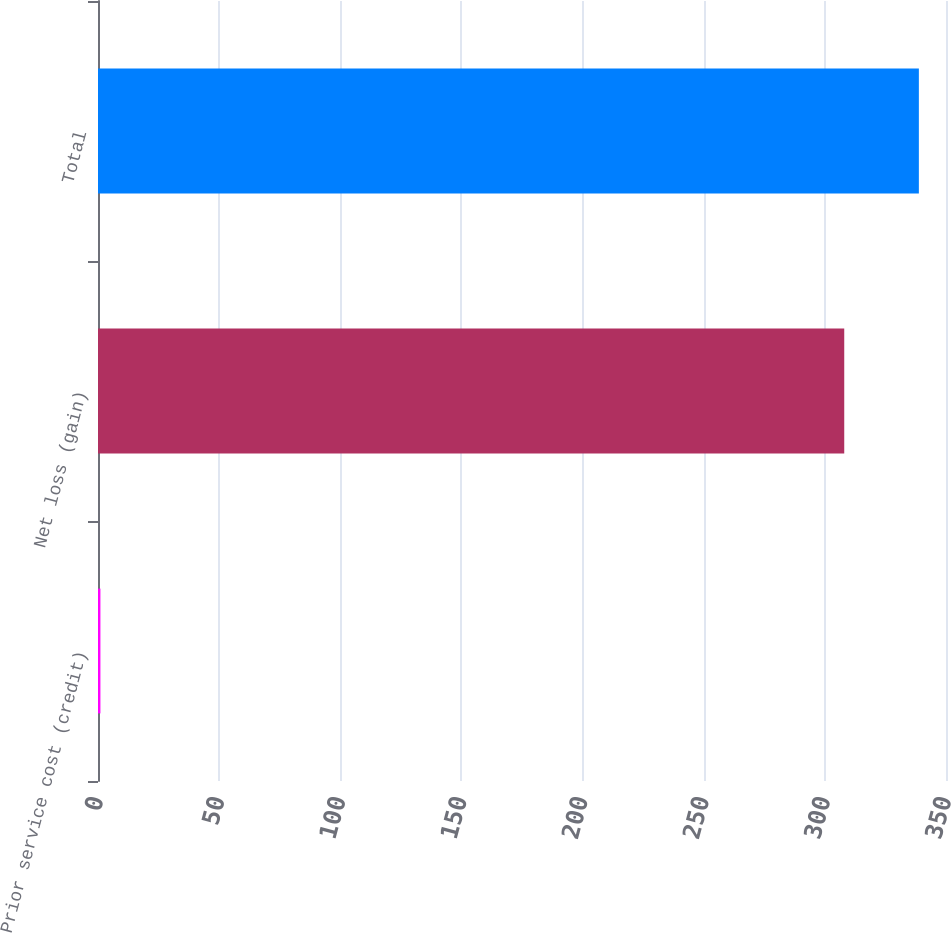<chart> <loc_0><loc_0><loc_500><loc_500><bar_chart><fcel>Prior service cost (credit)<fcel>Net loss (gain)<fcel>Total<nl><fcel>1<fcel>308<fcel>338.8<nl></chart> 